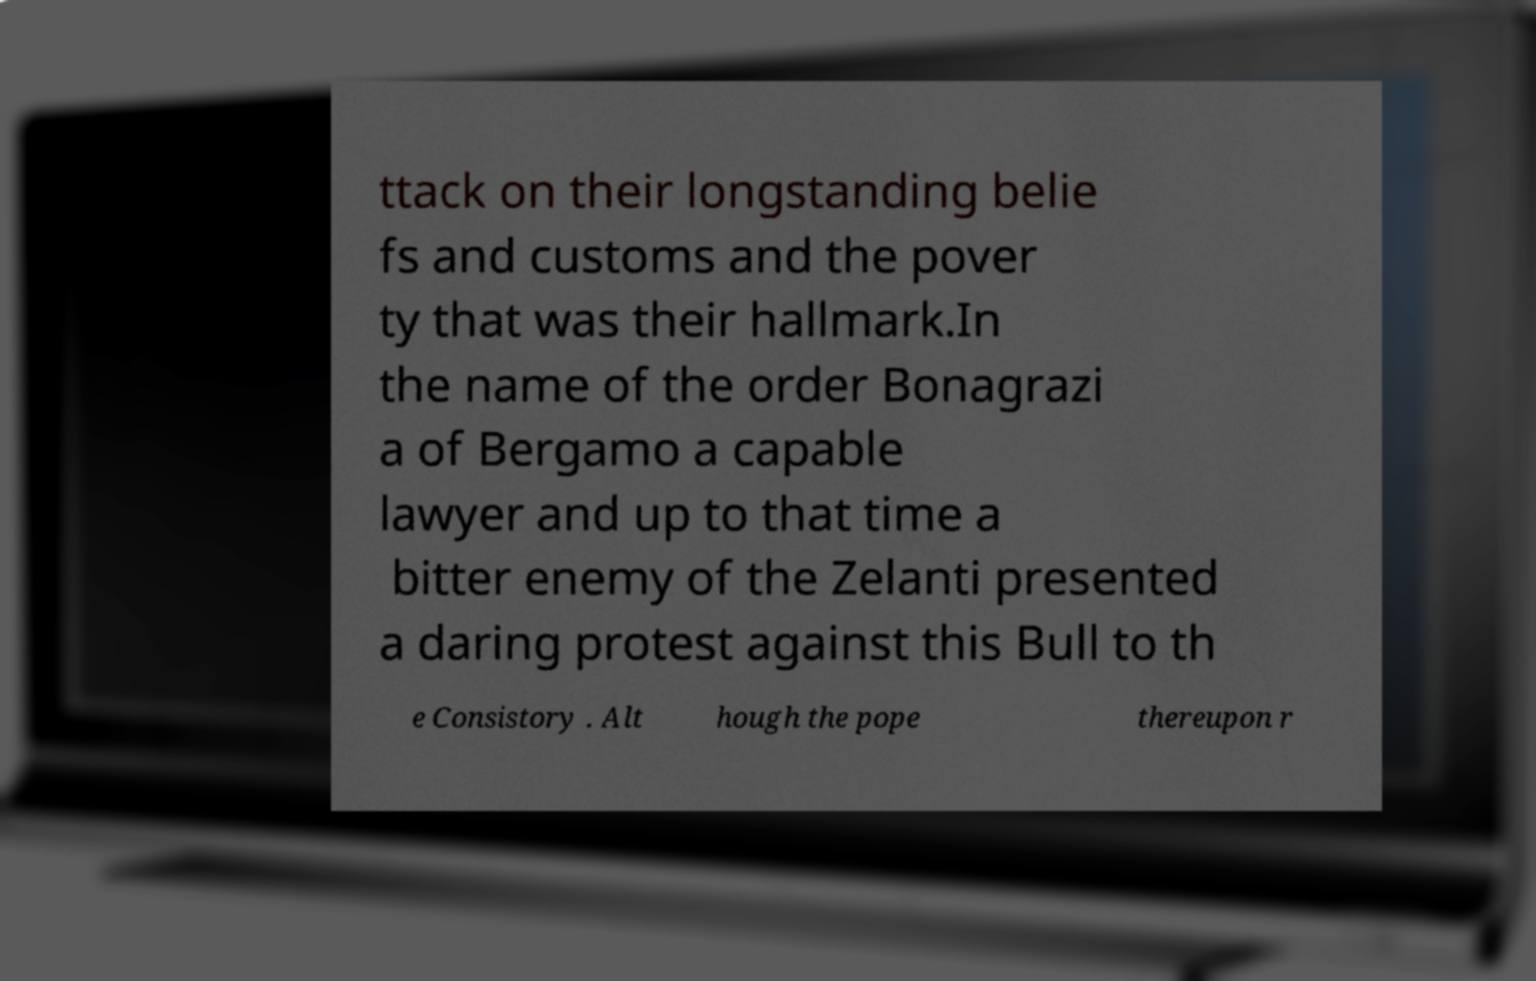Could you assist in decoding the text presented in this image and type it out clearly? ttack on their longstanding belie fs and customs and the pover ty that was their hallmark.In the name of the order Bonagrazi a of Bergamo a capable lawyer and up to that time a bitter enemy of the Zelanti presented a daring protest against this Bull to th e Consistory . Alt hough the pope thereupon r 